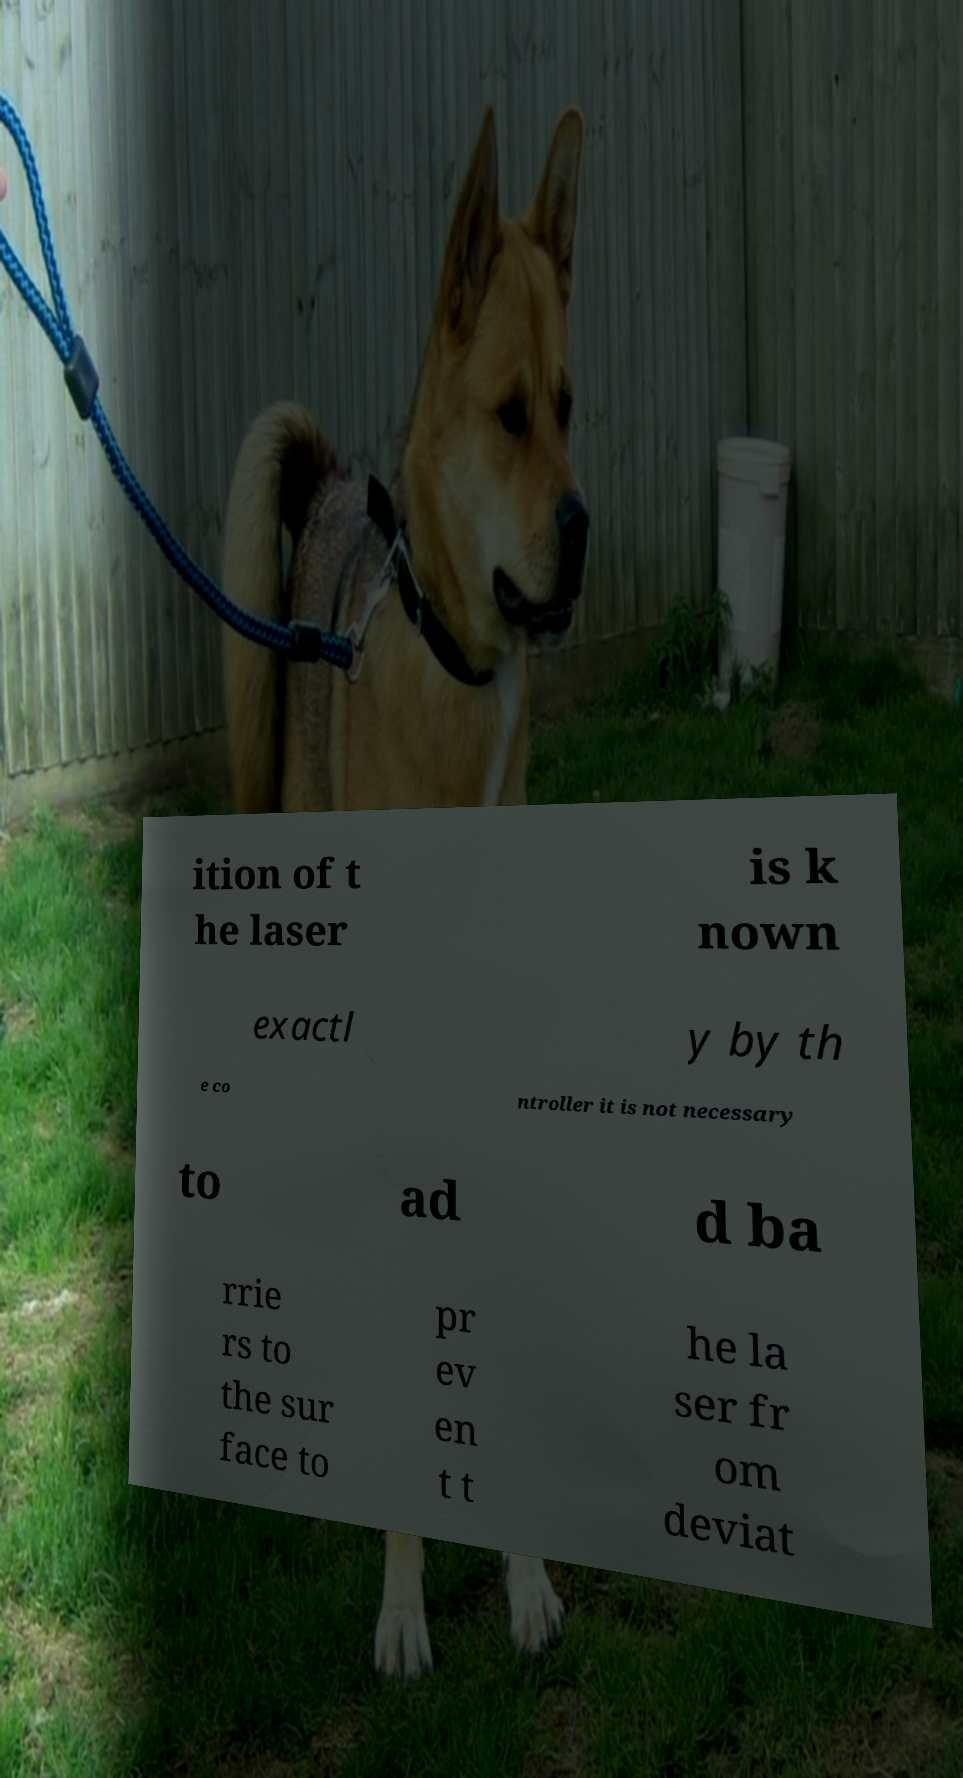What messages or text are displayed in this image? I need them in a readable, typed format. ition of t he laser is k nown exactl y by th e co ntroller it is not necessary to ad d ba rrie rs to the sur face to pr ev en t t he la ser fr om deviat 